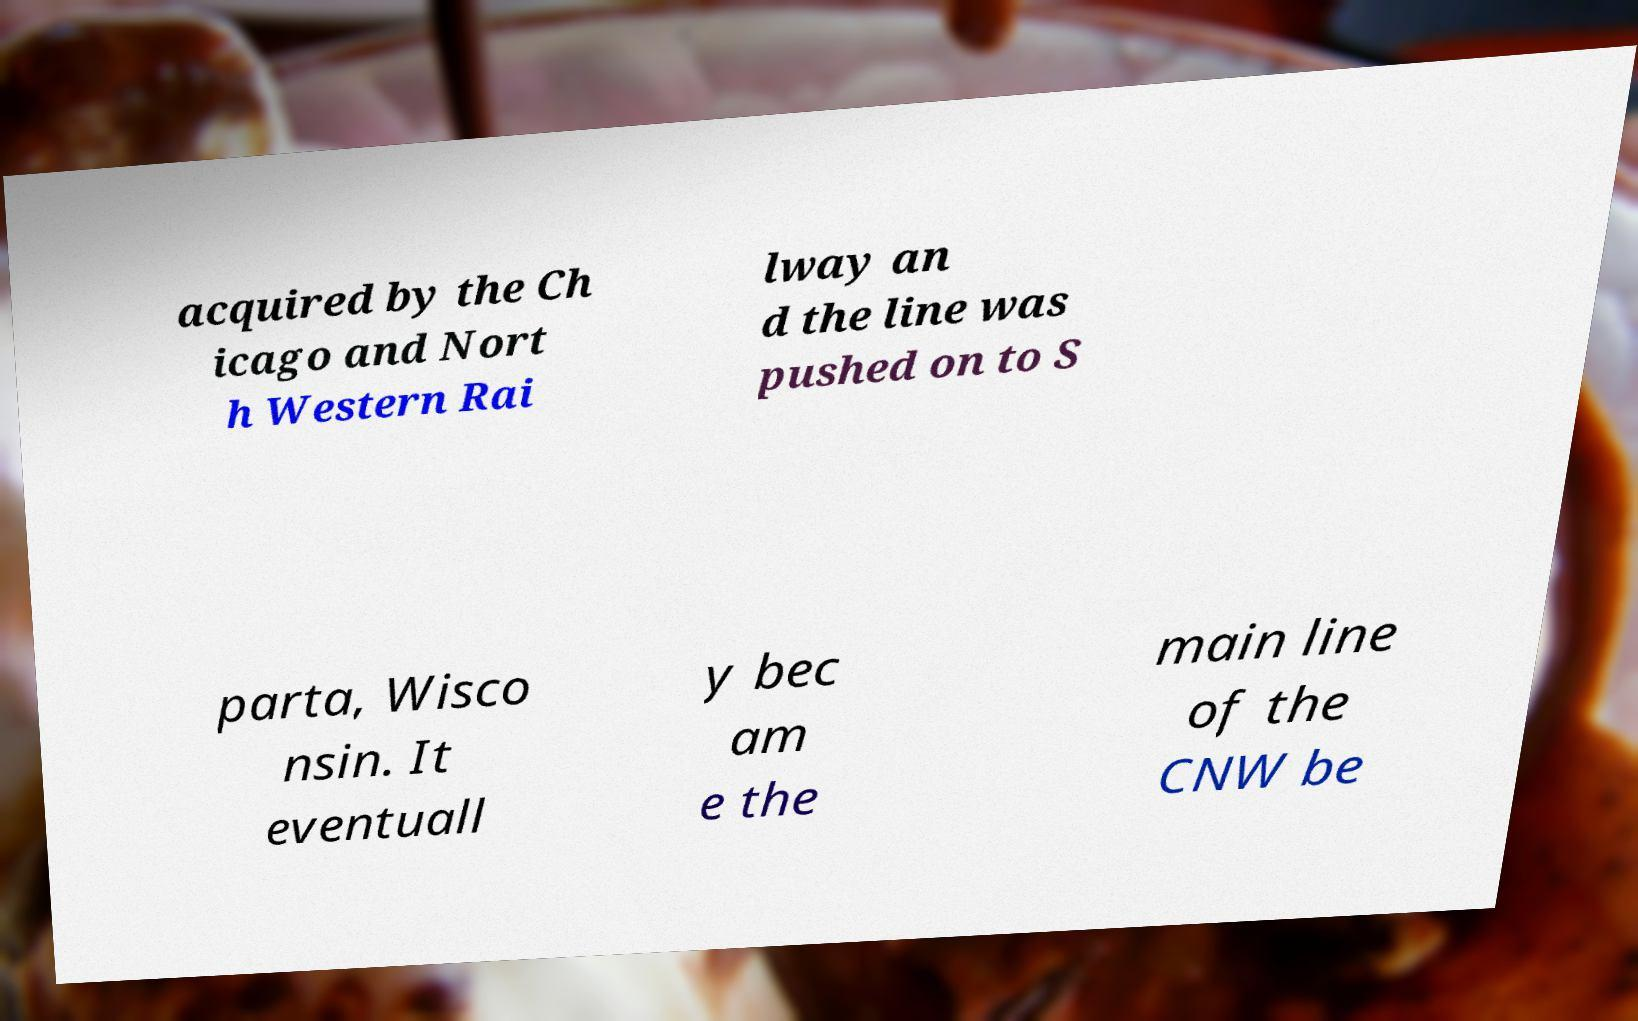Please identify and transcribe the text found in this image. acquired by the Ch icago and Nort h Western Rai lway an d the line was pushed on to S parta, Wisco nsin. It eventuall y bec am e the main line of the CNW be 